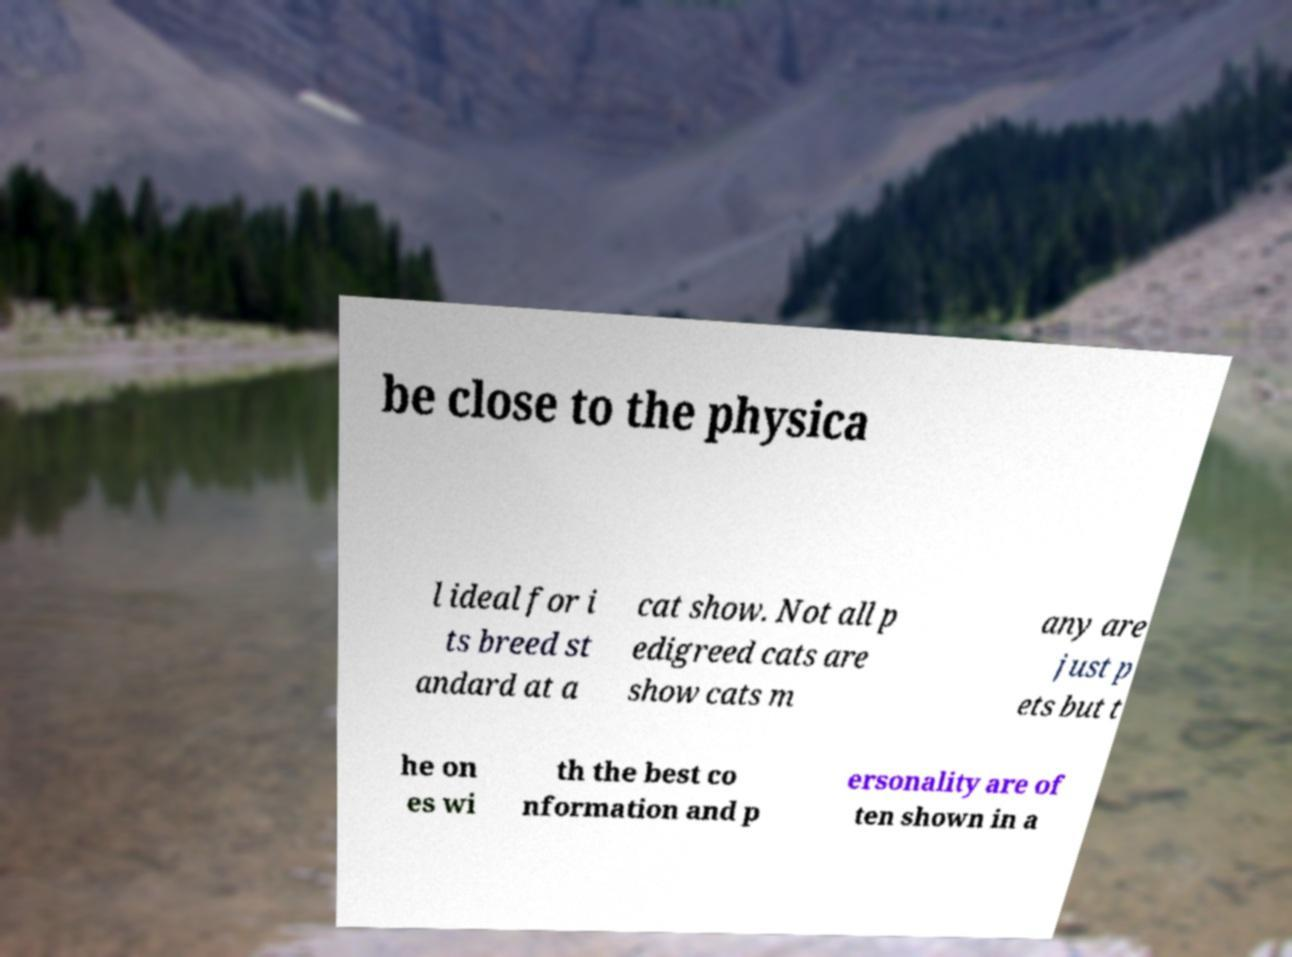What messages or text are displayed in this image? I need them in a readable, typed format. be close to the physica l ideal for i ts breed st andard at a cat show. Not all p edigreed cats are show cats m any are just p ets but t he on es wi th the best co nformation and p ersonality are of ten shown in a 